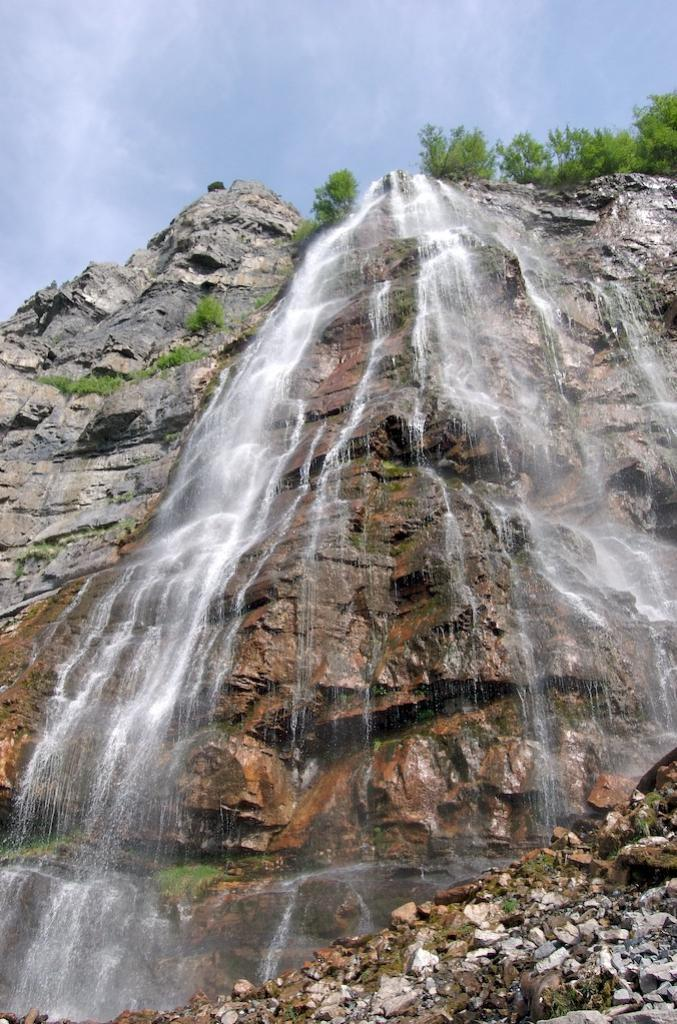What type of living organisms can be seen in the image? Plants can be seen in the image. What color are the plants in the image? The plants are green. What natural phenomenon is occurring in the image? Water is falling from the mountains in the image. What is the color of the sky in the image? The sky is white in the image. What type of writing can be seen on the tent in the image? There is no tent present in the image, so there is no writing to be seen. 